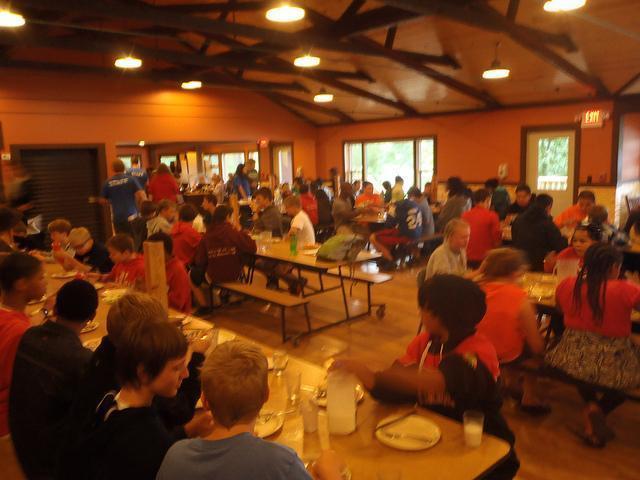How many people are visible?
Give a very brief answer. 10. 